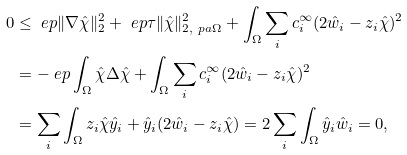<formula> <loc_0><loc_0><loc_500><loc_500>0 & \leq \ e p \| \nabla \hat { \chi } \| _ { 2 } ^ { 2 } + \ e p \tau \| \hat { \chi } \| _ { 2 , \ p a \Omega } ^ { 2 } + \int _ { \Omega } \sum _ { i } c _ { i } ^ { \infty } ( 2 \hat { w } _ { i } - z _ { i } \hat { \chi } ) ^ { 2 } \\ & = - \ e p \int _ { \Omega } \hat { \chi } \Delta \hat { \chi } + \int _ { \Omega } \sum _ { i } c _ { i } ^ { \infty } ( 2 \hat { w } _ { i } - z _ { i } \hat { \chi } ) ^ { 2 } \\ & = \sum _ { i } \int _ { \Omega } z _ { i } \hat { \chi } \hat { y } _ { i } + \hat { y } _ { i } ( 2 \hat { w } _ { i } - z _ { i } \hat { \chi } ) = 2 \sum _ { i } \int _ { \Omega } \hat { y } _ { i } \hat { w } _ { i } = 0 ,</formula> 